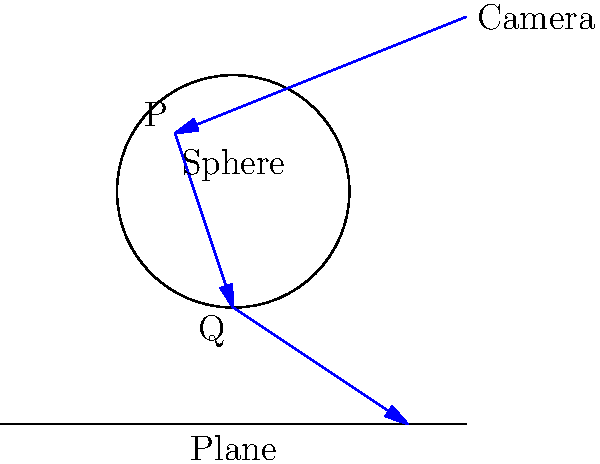In the given ray tracing diagram, a ray is cast from the camera and intersects a sphere at point P, then reflects and intersects a plane at point Q. Assuming the sphere is centered at (0,0) with radius 1, and the plane is at y=-2, how would you implement the calculation of the reflected ray direction at point P? To calculate the reflected ray direction at point P, we need to follow these steps:

1. Calculate the normal vector at point P:
   The normal vector $\mathbf{N}$ at any point on a sphere is the normalized vector from the sphere's center to that point.
   $\mathbf{N} = \frac{\mathbf{P} - \mathbf{C}}{|\mathbf{P} - \mathbf{C}|}$, where $\mathbf{C}$ is the sphere's center (0,0).

2. Calculate the incident ray direction:
   The incident ray direction $\mathbf{I}$ is the normalized vector from the camera to point P.

3. Use the reflection formula:
   The reflected ray direction $\mathbf{R}$ is given by:
   $\mathbf{R} = \mathbf{I} - 2(\mathbf{I} \cdot \mathbf{N})\mathbf{N}$

4. Implement in code:
   ```
   vec3 calculateReflectedRay(vec3 P, vec3 I) {
       vec3 N = normalize(P - vec3(0,0,0));  // Sphere center is (0,0,0)
       return normalize(I - 2 * dot(I, N) * N);
   }
   ```

5. Normalize the result:
   Ensure the reflected ray direction is a unit vector by normalizing it.

This implementation assumes all vectors are in 3D space (vec3) and that standard vector operations (dot product, normalization) are available.
Answer: $\mathbf{R} = \text{normalize}(\mathbf{I} - 2(\mathbf{I} \cdot \mathbf{N})\mathbf{N})$ 